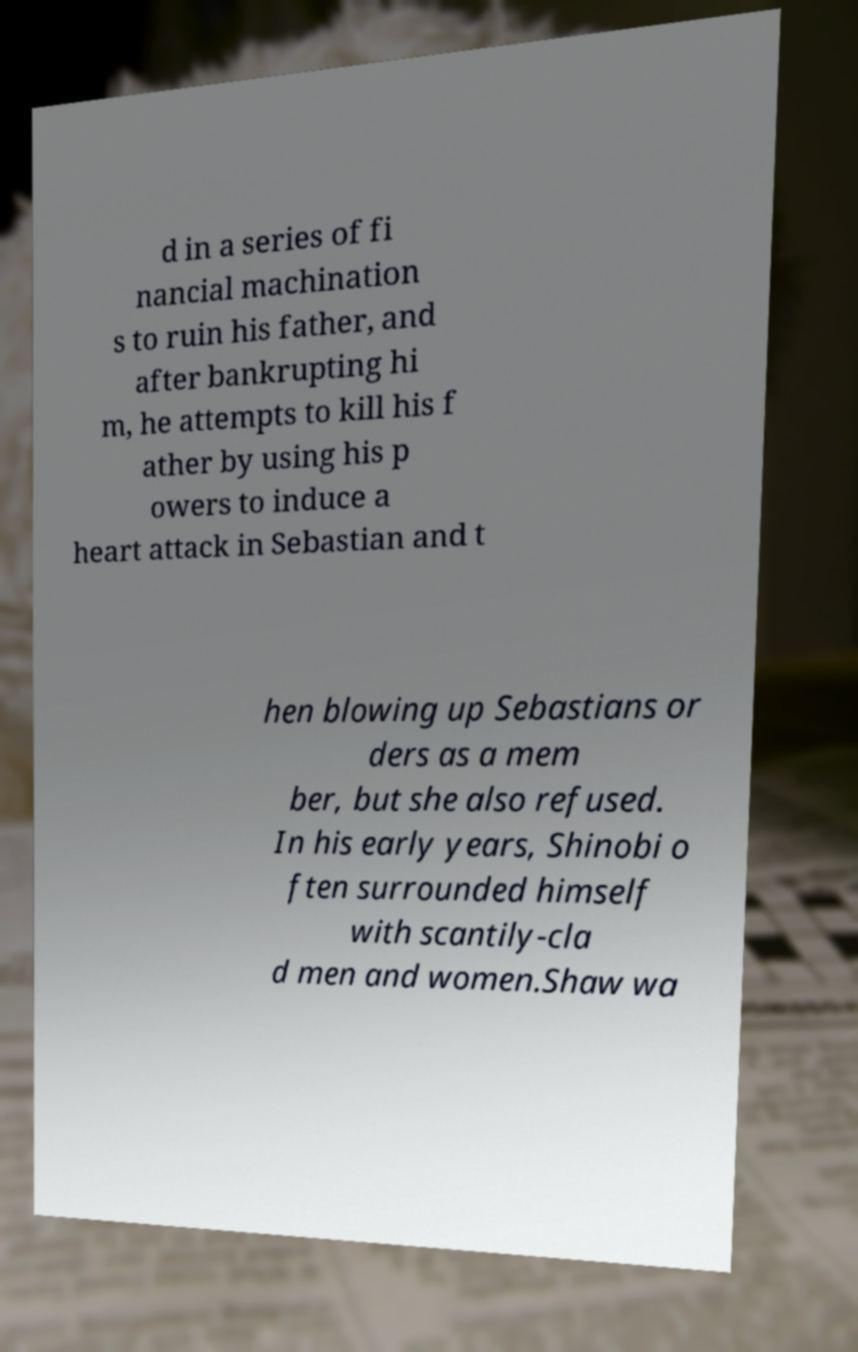I need the written content from this picture converted into text. Can you do that? d in a series of fi nancial machination s to ruin his father, and after bankrupting hi m, he attempts to kill his f ather by using his p owers to induce a heart attack in Sebastian and t hen blowing up Sebastians or ders as a mem ber, but she also refused. In his early years, Shinobi o ften surrounded himself with scantily-cla d men and women.Shaw wa 